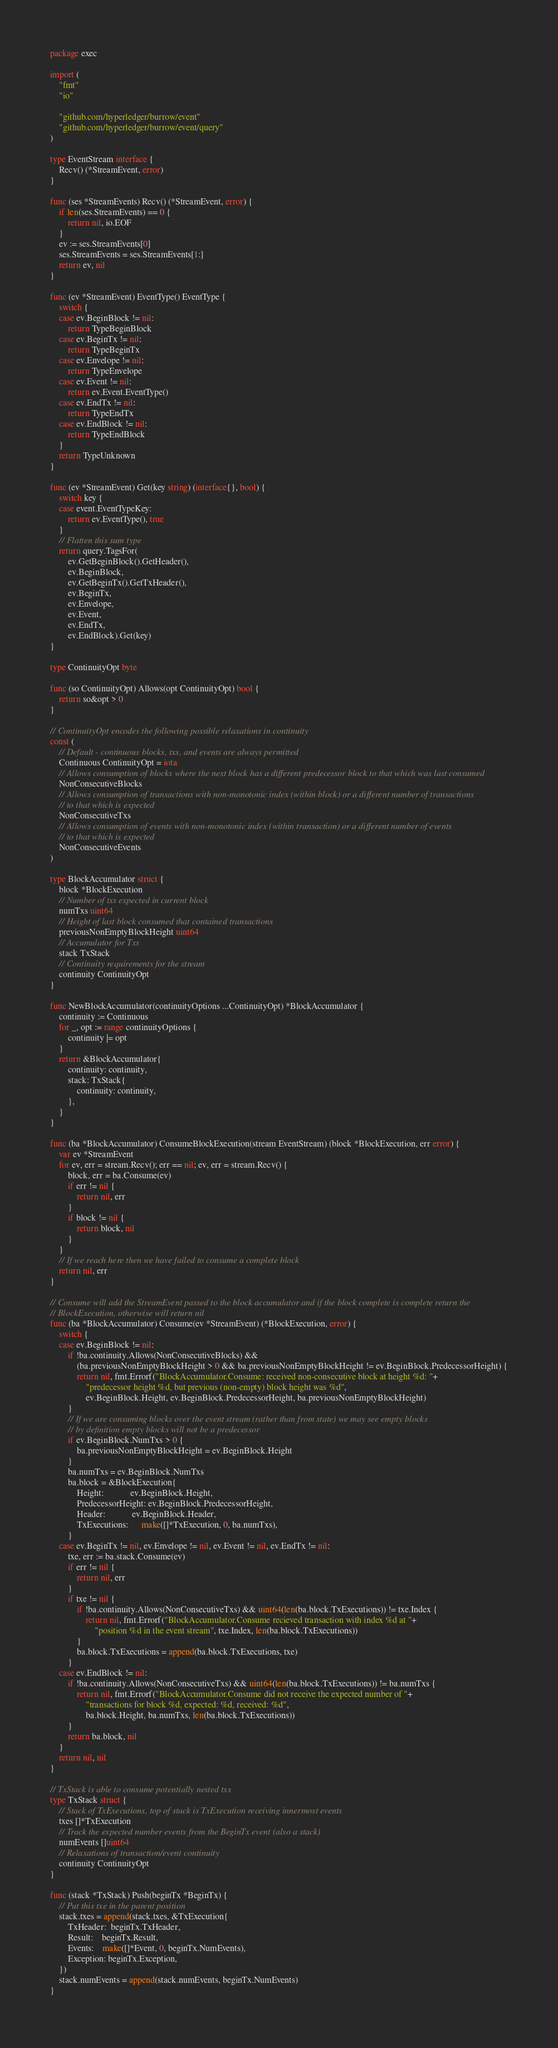Convert code to text. <code><loc_0><loc_0><loc_500><loc_500><_Go_>package exec

import (
	"fmt"
	"io"

	"github.com/hyperledger/burrow/event"
	"github.com/hyperledger/burrow/event/query"
)

type EventStream interface {
	Recv() (*StreamEvent, error)
}

func (ses *StreamEvents) Recv() (*StreamEvent, error) {
	if len(ses.StreamEvents) == 0 {
		return nil, io.EOF
	}
	ev := ses.StreamEvents[0]
	ses.StreamEvents = ses.StreamEvents[1:]
	return ev, nil
}

func (ev *StreamEvent) EventType() EventType {
	switch {
	case ev.BeginBlock != nil:
		return TypeBeginBlock
	case ev.BeginTx != nil:
		return TypeBeginTx
	case ev.Envelope != nil:
		return TypeEnvelope
	case ev.Event != nil:
		return ev.Event.EventType()
	case ev.EndTx != nil:
		return TypeEndTx
	case ev.EndBlock != nil:
		return TypeEndBlock
	}
	return TypeUnknown
}

func (ev *StreamEvent) Get(key string) (interface{}, bool) {
	switch key {
	case event.EventTypeKey:
		return ev.EventType(), true
	}
	// Flatten this sum type
	return query.TagsFor(
		ev.GetBeginBlock().GetHeader(),
		ev.BeginBlock,
		ev.GetBeginTx().GetTxHeader(),
		ev.BeginTx,
		ev.Envelope,
		ev.Event,
		ev.EndTx,
		ev.EndBlock).Get(key)
}

type ContinuityOpt byte

func (so ContinuityOpt) Allows(opt ContinuityOpt) bool {
	return so&opt > 0
}

// ContinuityOpt encodes the following possible relaxations in continuity
const (
	// Default - continuous blocks, txs, and events are always permitted
	Continuous ContinuityOpt = iota
	// Allows consumption of blocks where the next block has a different predecessor block to that which was last consumed
	NonConsecutiveBlocks
	// Allows consumption of transactions with non-monotonic index (within block) or a different number of transactions
	// to that which is expected
	NonConsecutiveTxs
	// Allows consumption of events with non-monotonic index (within transaction) or a different number of events
	// to that which is expected
	NonConsecutiveEvents
)

type BlockAccumulator struct {
	block *BlockExecution
	// Number of txs expected in current block
	numTxs uint64
	// Height of last block consumed that contained transactions
	previousNonEmptyBlockHeight uint64
	// Accumulator for Txs
	stack TxStack
	// Continuity requirements for the stream
	continuity ContinuityOpt
}

func NewBlockAccumulator(continuityOptions ...ContinuityOpt) *BlockAccumulator {
	continuity := Continuous
	for _, opt := range continuityOptions {
		continuity |= opt
	}
	return &BlockAccumulator{
		continuity: continuity,
		stack: TxStack{
			continuity: continuity,
		},
	}
}

func (ba *BlockAccumulator) ConsumeBlockExecution(stream EventStream) (block *BlockExecution, err error) {
	var ev *StreamEvent
	for ev, err = stream.Recv(); err == nil; ev, err = stream.Recv() {
		block, err = ba.Consume(ev)
		if err != nil {
			return nil, err
		}
		if block != nil {
			return block, nil
		}
	}
	// If we reach here then we have failed to consume a complete block
	return nil, err
}

// Consume will add the StreamEvent passed to the block accumulator and if the block complete is complete return the
// BlockExecution, otherwise will return nil
func (ba *BlockAccumulator) Consume(ev *StreamEvent) (*BlockExecution, error) {
	switch {
	case ev.BeginBlock != nil:
		if !ba.continuity.Allows(NonConsecutiveBlocks) &&
			(ba.previousNonEmptyBlockHeight > 0 && ba.previousNonEmptyBlockHeight != ev.BeginBlock.PredecessorHeight) {
			return nil, fmt.Errorf("BlockAccumulator.Consume: received non-consecutive block at height %d: "+
				"predecessor height %d, but previous (non-empty) block height was %d",
				ev.BeginBlock.Height, ev.BeginBlock.PredecessorHeight, ba.previousNonEmptyBlockHeight)
		}
		// If we are consuming blocks over the event stream (rather than from state) we may see empty blocks
		// by definition empty blocks will not be a predecessor
		if ev.BeginBlock.NumTxs > 0 {
			ba.previousNonEmptyBlockHeight = ev.BeginBlock.Height
		}
		ba.numTxs = ev.BeginBlock.NumTxs
		ba.block = &BlockExecution{
			Height:            ev.BeginBlock.Height,
			PredecessorHeight: ev.BeginBlock.PredecessorHeight,
			Header:            ev.BeginBlock.Header,
			TxExecutions:      make([]*TxExecution, 0, ba.numTxs),
		}
	case ev.BeginTx != nil, ev.Envelope != nil, ev.Event != nil, ev.EndTx != nil:
		txe, err := ba.stack.Consume(ev)
		if err != nil {
			return nil, err
		}
		if txe != nil {
			if !ba.continuity.Allows(NonConsecutiveTxs) && uint64(len(ba.block.TxExecutions)) != txe.Index {
				return nil, fmt.Errorf("BlockAccumulator.Consume recieved transaction with index %d at "+
					"position %d in the event stream", txe.Index, len(ba.block.TxExecutions))
			}
			ba.block.TxExecutions = append(ba.block.TxExecutions, txe)
		}
	case ev.EndBlock != nil:
		if !ba.continuity.Allows(NonConsecutiveTxs) && uint64(len(ba.block.TxExecutions)) != ba.numTxs {
			return nil, fmt.Errorf("BlockAccumulator.Consume did not receive the expected number of "+
				"transactions for block %d, expected: %d, received: %d",
				ba.block.Height, ba.numTxs, len(ba.block.TxExecutions))
		}
		return ba.block, nil
	}
	return nil, nil
}

// TxStack is able to consume potentially nested txs
type TxStack struct {
	// Stack of TxExecutions, top of stack is TxExecution receiving innermost events
	txes []*TxExecution
	// Track the expected number events from the BeginTx event (also a stack)
	numEvents []uint64
	// Relaxations of transaction/event continuity
	continuity ContinuityOpt
}

func (stack *TxStack) Push(beginTx *BeginTx) {
	// Put this txe in the parent position
	stack.txes = append(stack.txes, &TxExecution{
		TxHeader:  beginTx.TxHeader,
		Result:    beginTx.Result,
		Events:    make([]*Event, 0, beginTx.NumEvents),
		Exception: beginTx.Exception,
	})
	stack.numEvents = append(stack.numEvents, beginTx.NumEvents)
}
</code> 